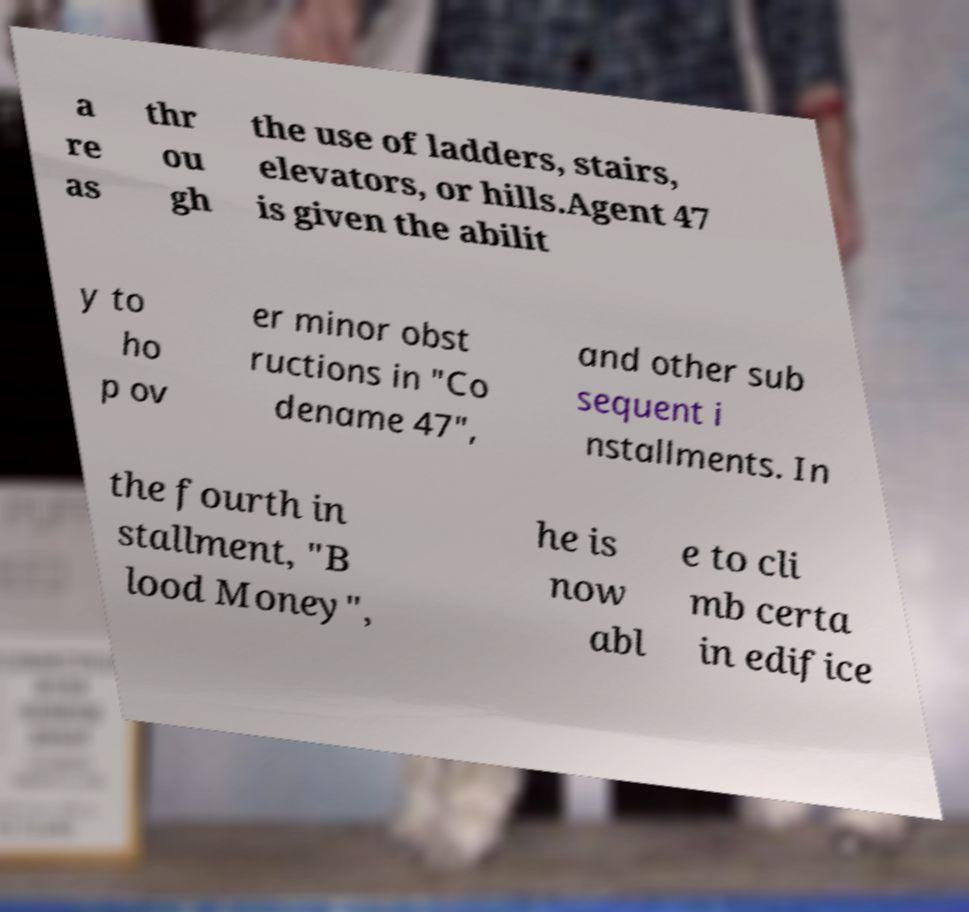For documentation purposes, I need the text within this image transcribed. Could you provide that? a re as thr ou gh the use of ladders, stairs, elevators, or hills.Agent 47 is given the abilit y to ho p ov er minor obst ructions in "Co dename 47", and other sub sequent i nstallments. In the fourth in stallment, "B lood Money", he is now abl e to cli mb certa in edifice 